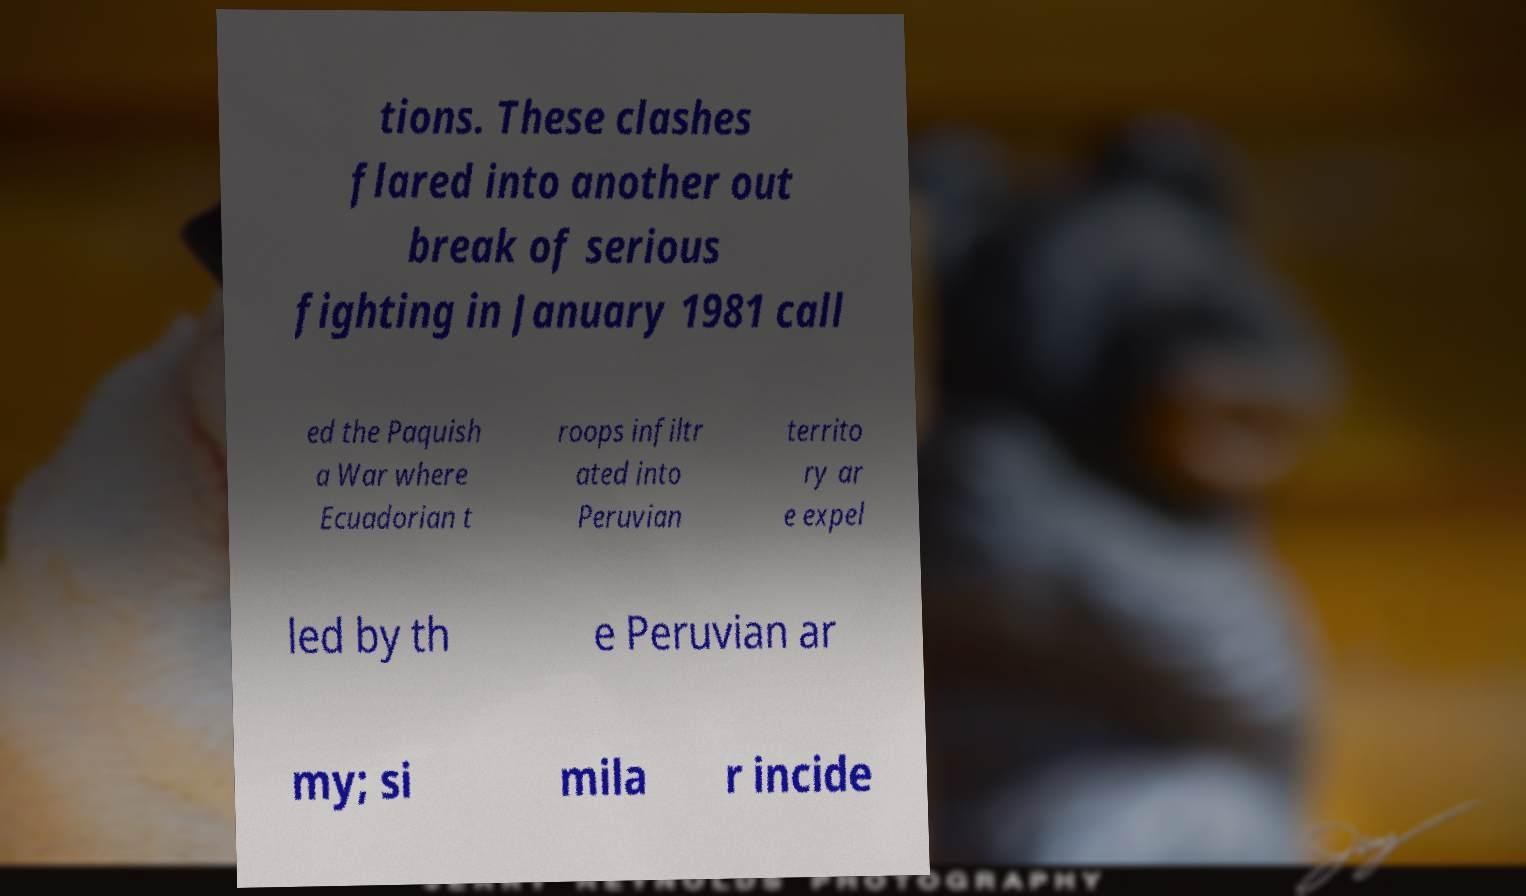What messages or text are displayed in this image? I need them in a readable, typed format. tions. These clashes flared into another out break of serious fighting in January 1981 call ed the Paquish a War where Ecuadorian t roops infiltr ated into Peruvian territo ry ar e expel led by th e Peruvian ar my; si mila r incide 